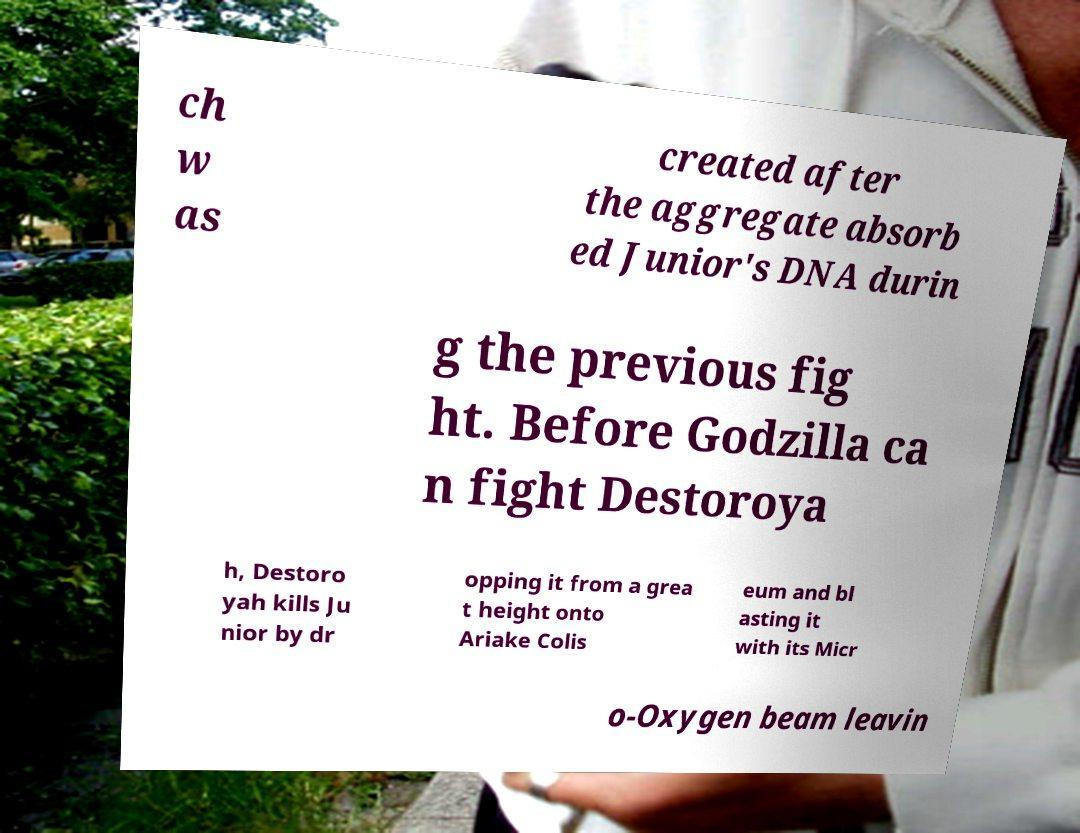There's text embedded in this image that I need extracted. Can you transcribe it verbatim? ch w as created after the aggregate absorb ed Junior's DNA durin g the previous fig ht. Before Godzilla ca n fight Destoroya h, Destoro yah kills Ju nior by dr opping it from a grea t height onto Ariake Colis eum and bl asting it with its Micr o-Oxygen beam leavin 